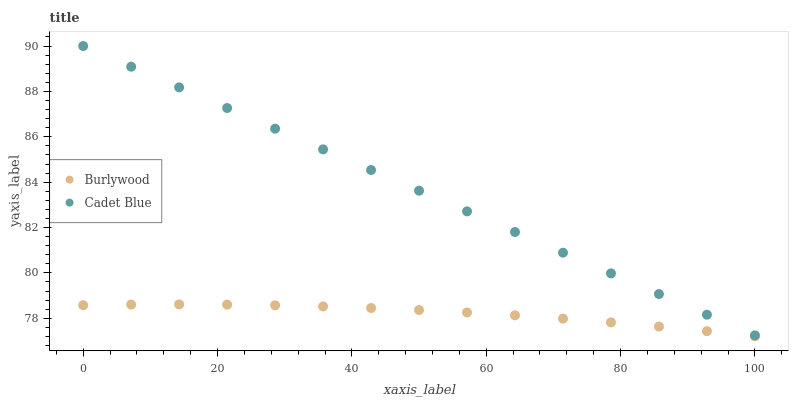Does Burlywood have the minimum area under the curve?
Answer yes or no. Yes. Does Cadet Blue have the maximum area under the curve?
Answer yes or no. Yes. Does Cadet Blue have the minimum area under the curve?
Answer yes or no. No. Is Cadet Blue the smoothest?
Answer yes or no. Yes. Is Burlywood the roughest?
Answer yes or no. Yes. Is Cadet Blue the roughest?
Answer yes or no. No. Does Burlywood have the lowest value?
Answer yes or no. Yes. Does Cadet Blue have the lowest value?
Answer yes or no. No. Does Cadet Blue have the highest value?
Answer yes or no. Yes. Is Burlywood less than Cadet Blue?
Answer yes or no. Yes. Is Cadet Blue greater than Burlywood?
Answer yes or no. Yes. Does Burlywood intersect Cadet Blue?
Answer yes or no. No. 